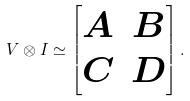Convert formula to latex. <formula><loc_0><loc_0><loc_500><loc_500>V \otimes I \simeq \begin{bmatrix} A & B \\ C & D \end{bmatrix} .</formula> 